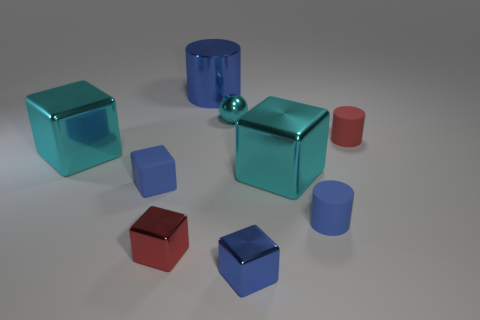There is a tiny red rubber cylinder; what number of blue metal cylinders are in front of it? In the visual scene depicted, there are no blue metal cylinders positioned in front of the tiny red rubber cylinder. Ensuring a clear understanding, the image presents a variety of geometric forms, some of which are indeed cylinders, but their arrangement does not place any blue ones directly in front of the red cylinder you mentioned. 